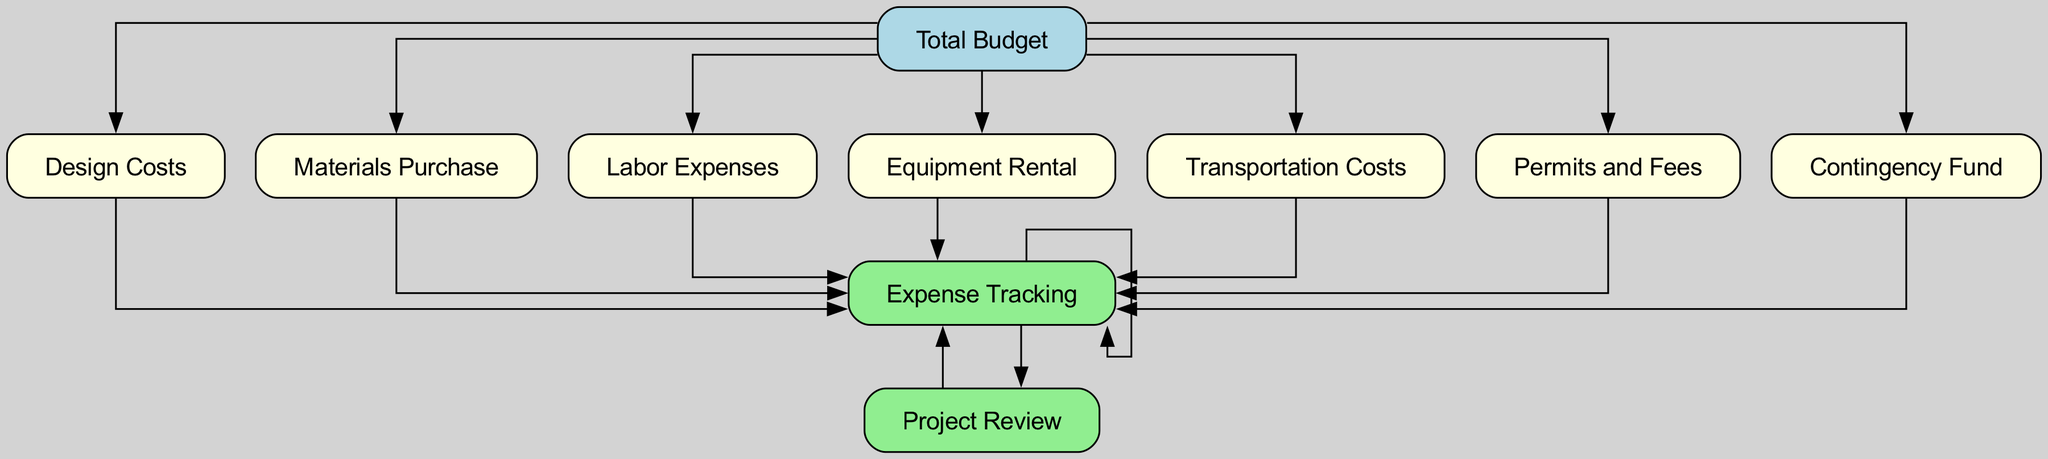What is the total number of nodes in the diagram? The diagram contains 10 elements that represent different aspects of budget allocation. Each unique budget category and process is represented as a node. Therefore, the total number of nodes is simply the count of these elements.
Answer: 10 What color represents the total budget? The total budget node is specifically colored light blue in the diagram, which distinguishes it from other nodes.
Answer: light blue Which node is directly linked to the contingency fund? The contingency fund has a direct link to the expense tracking node, indicating that all expense categories ultimately relate to tracking realized expenses, including any contingency funds used.
Answer: Expense Tracking How many expense categories branch out from the total budget? There are six direct branches extending from the total budget node, connecting to design costs, materials purchase, labor expenses, equipment rental, transportation costs, and permits and fees. This indicates a structure of specific expenses derived from the total budget.
Answer: 6 What is the flow direction of the expense tracking node? The expense tracking node is positioned to receive inputs from all expense categories and outputs to the project review node, indicating that it monitors and directs expenses towards analysis. Thus, the flow direction is from expense categories to the project review.
Answer: Outward to Project Review What is the relationship between the project review and expense tracking? The project review node is dependent on and follows the expense tracking node, which signifies that the analysis of expenses is based on the tracking of all expenditures collected beforehand during the budget execution.
Answer: Project Review follows Expense Tracking What is the role of the contingency fund? The contingency fund node signifies reserved funds for unexpected expenses, indicating its function within the budget structure designed to cover unforeseen costs that may arise during landscaping projects.
Answer: Reserved funds for unexpected expenses How many nodes influence the expense tracking? The expense tracking node is influenced by all six expense categories that branch out from the total budget, making it the recipient of multiple inputs necessary for tracking the expenses effectively.
Answer: 6 What is the final step after expense tracking in the flow? Once the expense tracking has collected and monitored all expenses, the final step in the flow is the project review, where the accumulated expenditures are analyzed against the planned budget.
Answer: Project Review 